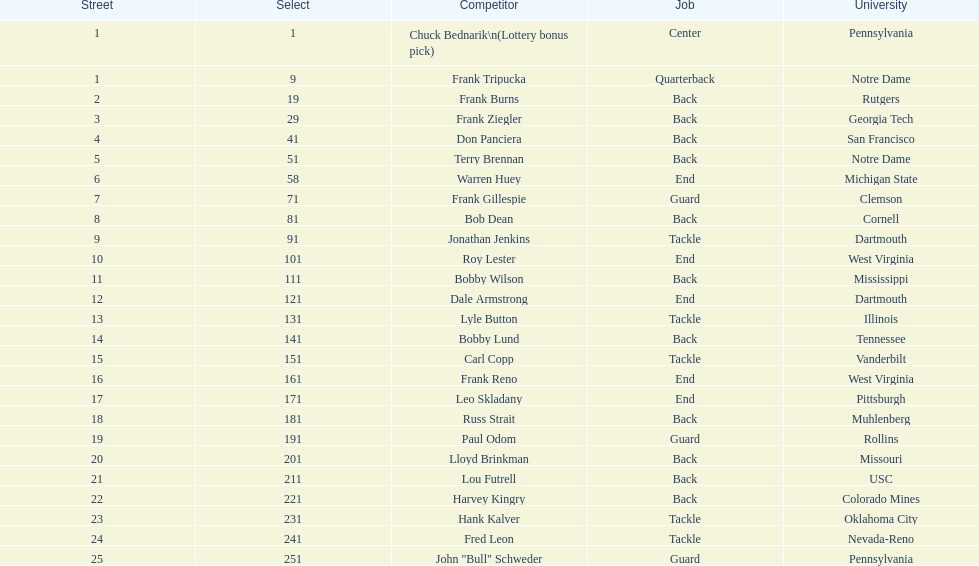Who has same position as frank gillespie? Paul Odom, John "Bull" Schweder. 